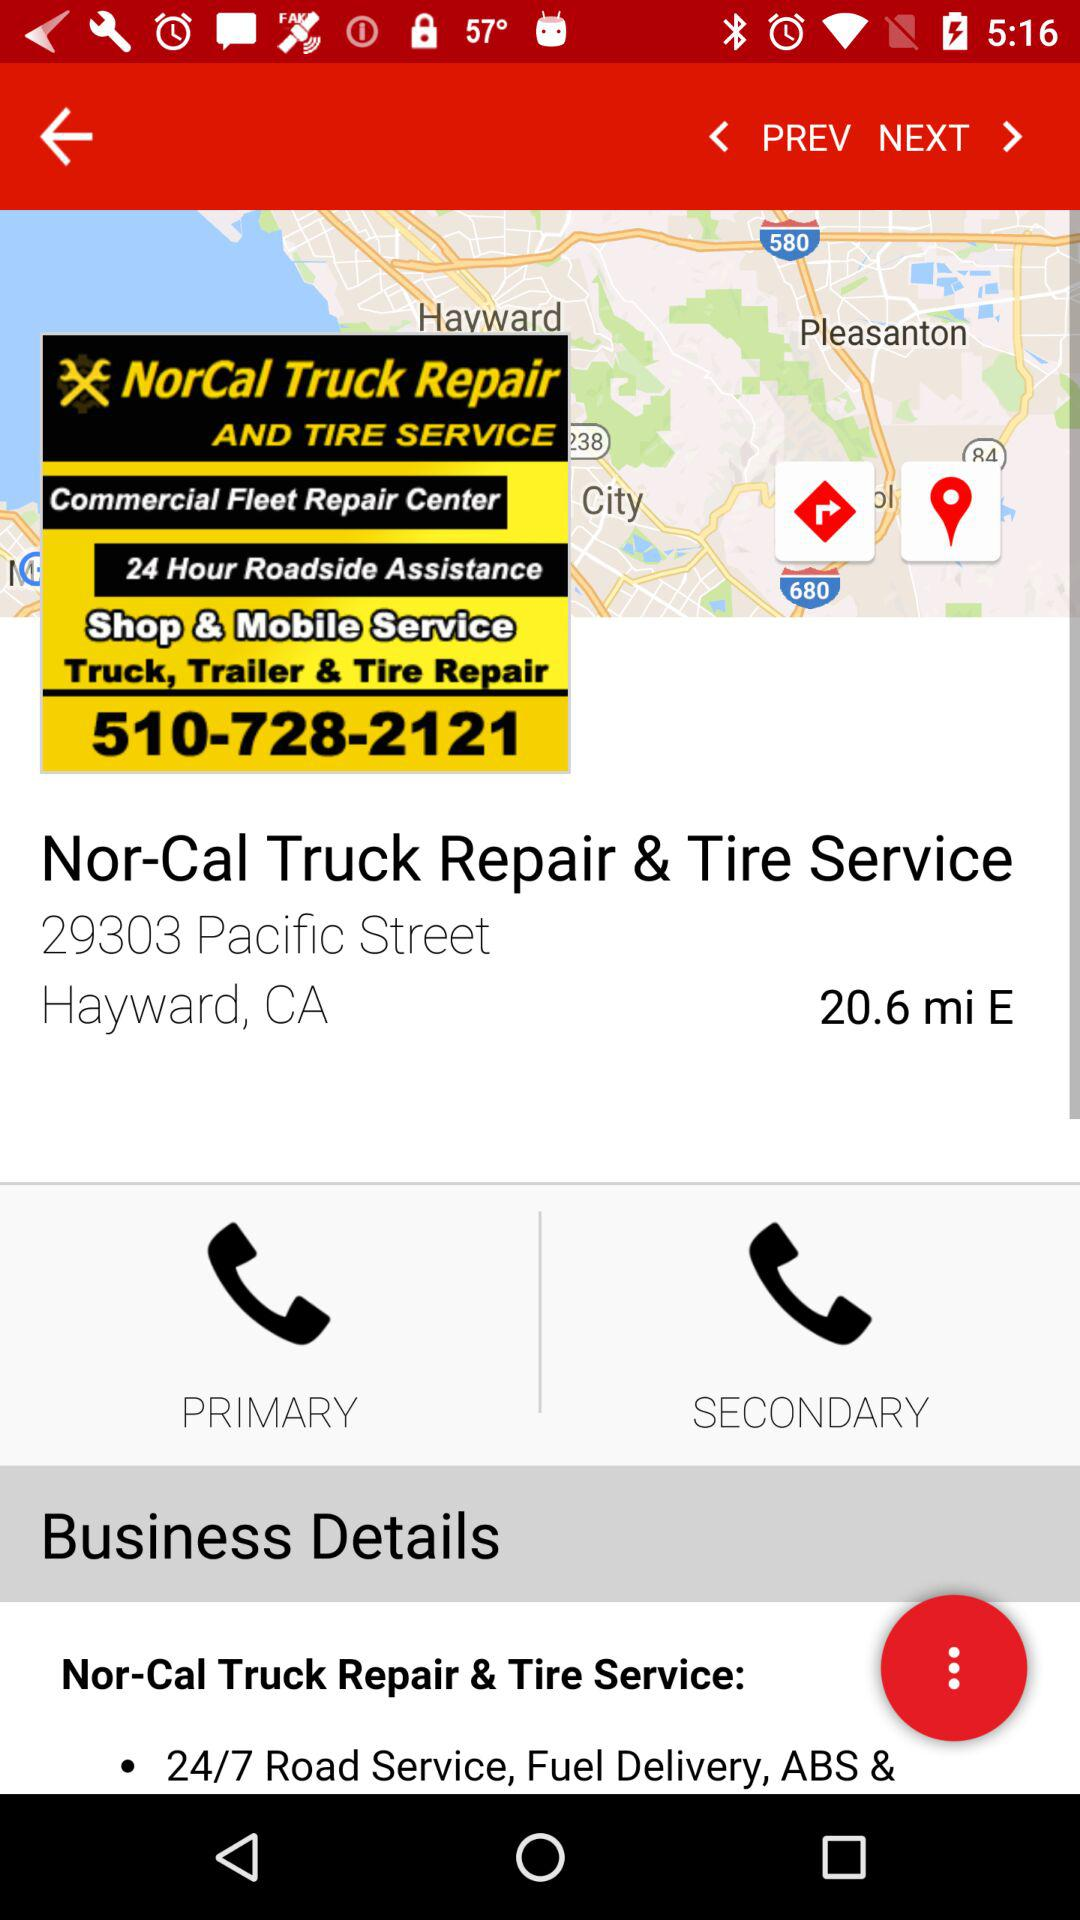What is the address of Nor-Cal Truck Repair & Tire Service? The address is 29303 Pacific Street, Hayward, CA. 